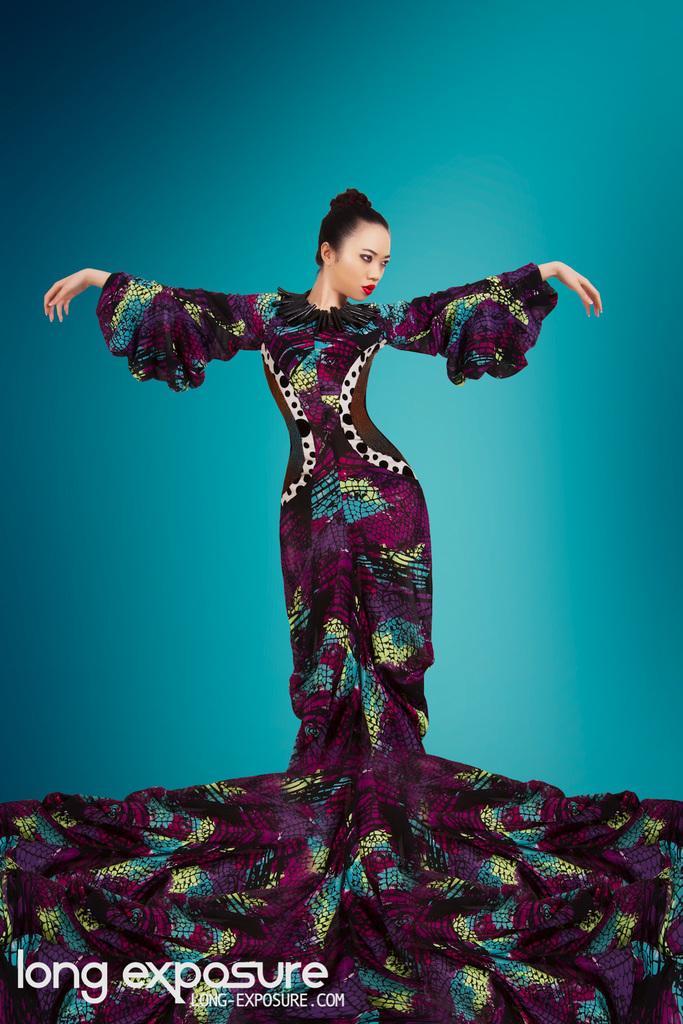How would you summarize this image in a sentence or two? In this picture we can see a woman and there is a watermark. 